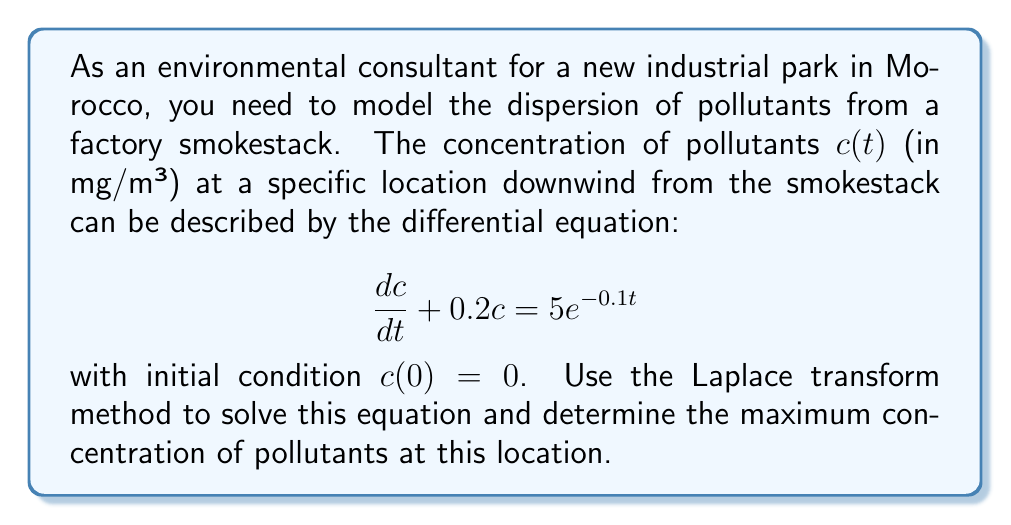Teach me how to tackle this problem. Let's solve this problem step by step using the Laplace transform method:

1) First, we take the Laplace transform of both sides of the equation:

   $\mathcal{L}\{\frac{dc}{dt} + 0.2c\} = \mathcal{L}\{5e^{-0.1t}\}$

2) Using the linearity property and the Laplace transform of the derivative:

   $s\mathcal{L}\{c\} - c(0) + 0.2\mathcal{L}\{c\} = \frac{5}{s+0.1}$

3) Let $C(s) = \mathcal{L}\{c\}$. Substituting $c(0) = 0$:

   $sC(s) + 0.2C(s) = \frac{5}{s+0.1}$

4) Factoring out $C(s)$:

   $C(s)(s + 0.2) = \frac{5}{s+0.1}$

5) Solving for $C(s)$:

   $C(s) = \frac{5}{(s+0.2)(s+0.1)}$

6) Using partial fraction decomposition:

   $C(s) = \frac{A}{s+0.2} + \frac{B}{s+0.1}$

   where $A = \frac{5}{0.1} = 50$ and $B = \frac{-5}{0.1} = -50$

7) Taking the inverse Laplace transform:

   $c(t) = 50e^{-0.2t} - 50e^{-0.1t}$

8) To find the maximum concentration, we differentiate $c(t)$ and set it to zero:

   $\frac{dc}{dt} = -10e^{-0.2t} + 5e^{-0.1t} = 0$

9) Solving this equation:

   $e^{0.1t} = 2$

   $t = \frac{\ln(2)}{0.1} \approx 6.93$ seconds

10) The maximum concentration occurs at this time. Substituting back into $c(t)$:

    $c_{max} = 50e^{-0.2(6.93)} - 50e^{-0.1(6.93)} \approx 8.52$ mg/m³
Answer: The maximum pollutant concentration at the specified location is approximately 8.52 mg/m³, occurring about 6.93 seconds after the release. 